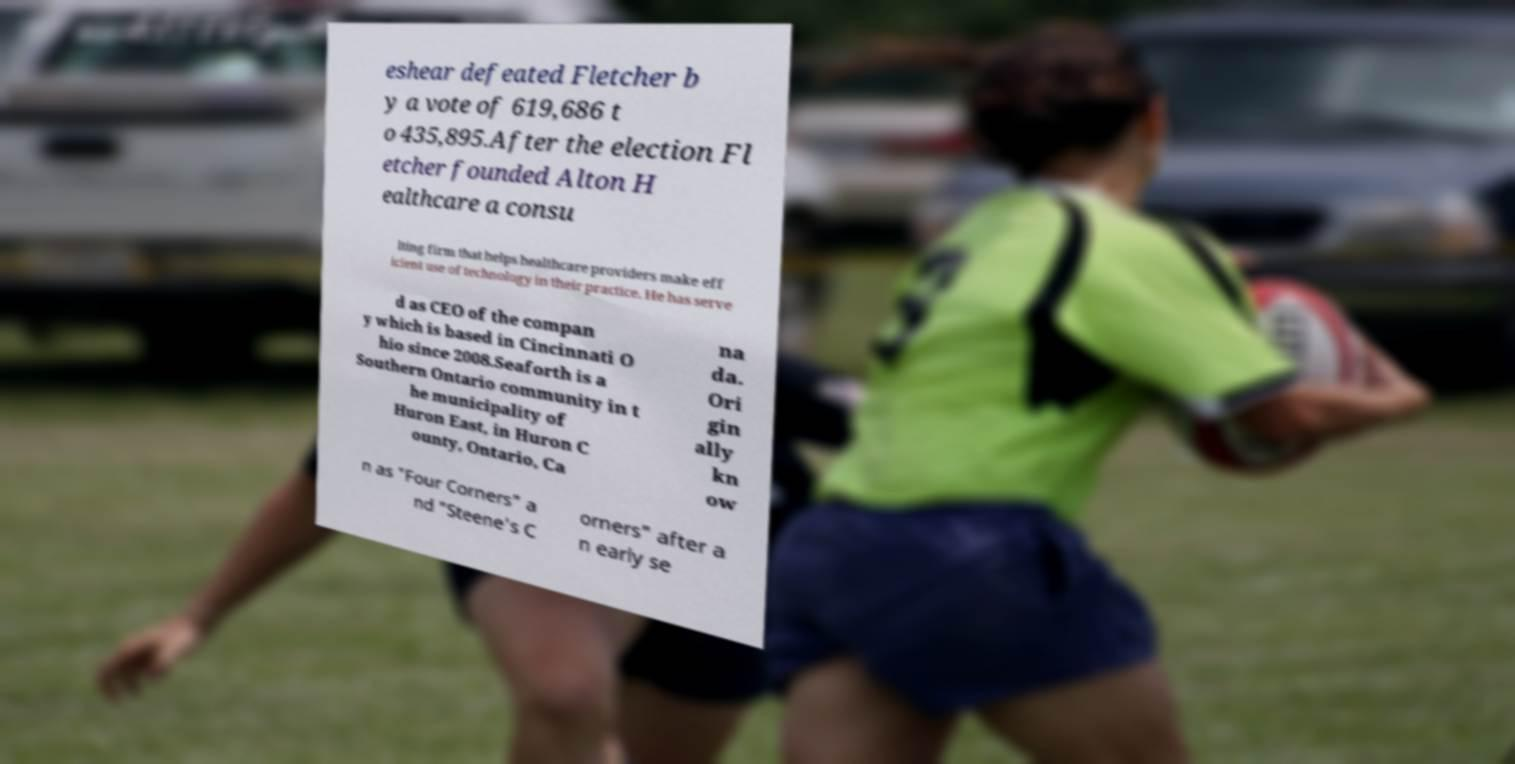Can you read and provide the text displayed in the image?This photo seems to have some interesting text. Can you extract and type it out for me? eshear defeated Fletcher b y a vote of 619,686 t o 435,895.After the election Fl etcher founded Alton H ealthcare a consu lting firm that helps healthcare providers make eff icient use of technology in their practice. He has serve d as CEO of the compan y which is based in Cincinnati O hio since 2008.Seaforth is a Southern Ontario community in t he municipality of Huron East, in Huron C ounty, Ontario, Ca na da. Ori gin ally kn ow n as "Four Corners" a nd "Steene's C orners" after a n early se 